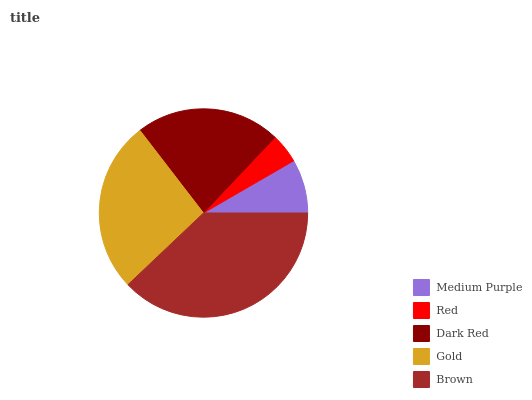Is Red the minimum?
Answer yes or no. Yes. Is Brown the maximum?
Answer yes or no. Yes. Is Dark Red the minimum?
Answer yes or no. No. Is Dark Red the maximum?
Answer yes or no. No. Is Dark Red greater than Red?
Answer yes or no. Yes. Is Red less than Dark Red?
Answer yes or no. Yes. Is Red greater than Dark Red?
Answer yes or no. No. Is Dark Red less than Red?
Answer yes or no. No. Is Dark Red the high median?
Answer yes or no. Yes. Is Dark Red the low median?
Answer yes or no. Yes. Is Gold the high median?
Answer yes or no. No. Is Red the low median?
Answer yes or no. No. 